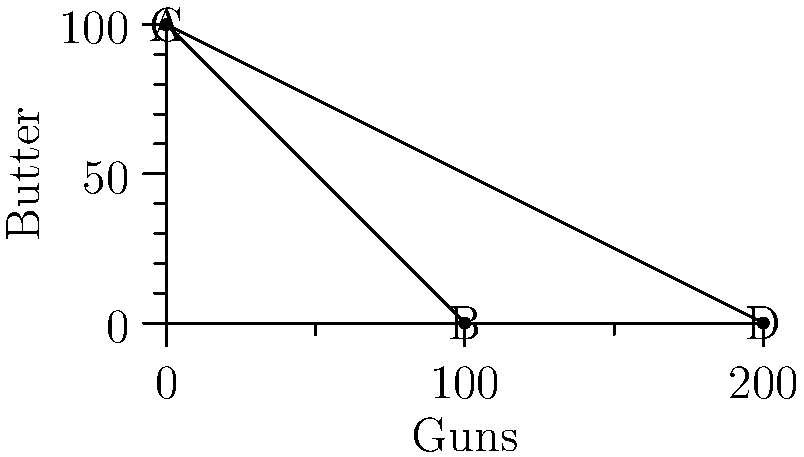The production possibility frontier (PPF) for an economy producing guns and butter is shown above. Curve AB represents the initial PPF, while curve CD represents the PPF after technological improvements in gun production. What is the opportunity cost of producing one additional unit of guns at point B on the initial PPF? To find the opportunity cost of producing one additional unit of guns at point B, we need to follow these steps:

1. Identify the initial PPF equation:
   The initial PPF is represented by the line AB, which has the equation:
   $$y = 100 - x$$
   where $y$ represents butter and $x$ represents guns.

2. Calculate the slope of the PPF:
   The slope of this line is -1, which means for every 1 unit increase in guns, there's a 1 unit decrease in butter.

3. Interpret the slope:
   In economics, the negative of the slope of the PPF represents the opportunity cost. 

4. Express the opportunity cost:
   Therefore, at point B (and indeed at any point on this linear PPF), the opportunity cost of producing one additional unit of guns is 1 unit of butter.

This constant opportunity cost is characteristic of a linear PPF, indicating that resources are equally efficient in producing both goods.
Answer: 1 unit of butter 